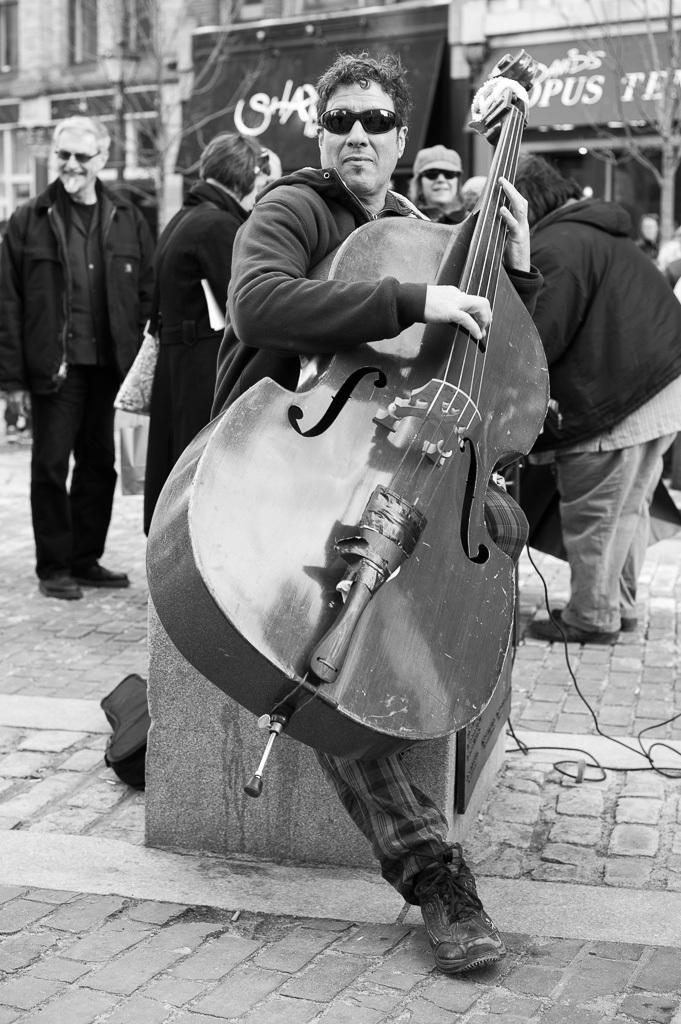Can you describe this image briefly? In this image we can see one big building, some trees, one banner with text and some objects are on the surface. There is one name board with text, some people standing, some wires and some people holding some objects. One man playing musical instrument and one board attached to the small pillar. 